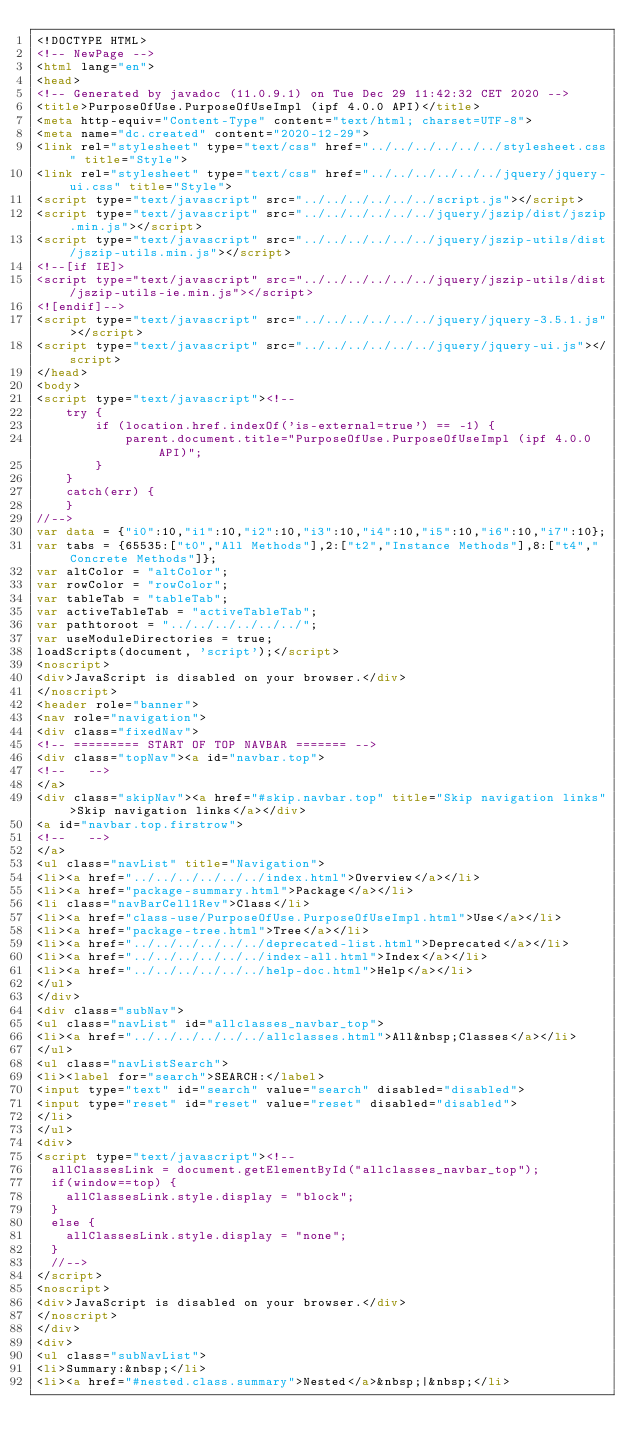Convert code to text. <code><loc_0><loc_0><loc_500><loc_500><_HTML_><!DOCTYPE HTML>
<!-- NewPage -->
<html lang="en">
<head>
<!-- Generated by javadoc (11.0.9.1) on Tue Dec 29 11:42:32 CET 2020 -->
<title>PurposeOfUse.PurposeOfUseImpl (ipf 4.0.0 API)</title>
<meta http-equiv="Content-Type" content="text/html; charset=UTF-8">
<meta name="dc.created" content="2020-12-29">
<link rel="stylesheet" type="text/css" href="../../../../../../stylesheet.css" title="Style">
<link rel="stylesheet" type="text/css" href="../../../../../../jquery/jquery-ui.css" title="Style">
<script type="text/javascript" src="../../../../../../script.js"></script>
<script type="text/javascript" src="../../../../../../jquery/jszip/dist/jszip.min.js"></script>
<script type="text/javascript" src="../../../../../../jquery/jszip-utils/dist/jszip-utils.min.js"></script>
<!--[if IE]>
<script type="text/javascript" src="../../../../../../jquery/jszip-utils/dist/jszip-utils-ie.min.js"></script>
<![endif]-->
<script type="text/javascript" src="../../../../../../jquery/jquery-3.5.1.js"></script>
<script type="text/javascript" src="../../../../../../jquery/jquery-ui.js"></script>
</head>
<body>
<script type="text/javascript"><!--
    try {
        if (location.href.indexOf('is-external=true') == -1) {
            parent.document.title="PurposeOfUse.PurposeOfUseImpl (ipf 4.0.0 API)";
        }
    }
    catch(err) {
    }
//-->
var data = {"i0":10,"i1":10,"i2":10,"i3":10,"i4":10,"i5":10,"i6":10,"i7":10};
var tabs = {65535:["t0","All Methods"],2:["t2","Instance Methods"],8:["t4","Concrete Methods"]};
var altColor = "altColor";
var rowColor = "rowColor";
var tableTab = "tableTab";
var activeTableTab = "activeTableTab";
var pathtoroot = "../../../../../../";
var useModuleDirectories = true;
loadScripts(document, 'script');</script>
<noscript>
<div>JavaScript is disabled on your browser.</div>
</noscript>
<header role="banner">
<nav role="navigation">
<div class="fixedNav">
<!-- ========= START OF TOP NAVBAR ======= -->
<div class="topNav"><a id="navbar.top">
<!--   -->
</a>
<div class="skipNav"><a href="#skip.navbar.top" title="Skip navigation links">Skip navigation links</a></div>
<a id="navbar.top.firstrow">
<!--   -->
</a>
<ul class="navList" title="Navigation">
<li><a href="../../../../../../index.html">Overview</a></li>
<li><a href="package-summary.html">Package</a></li>
<li class="navBarCell1Rev">Class</li>
<li><a href="class-use/PurposeOfUse.PurposeOfUseImpl.html">Use</a></li>
<li><a href="package-tree.html">Tree</a></li>
<li><a href="../../../../../../deprecated-list.html">Deprecated</a></li>
<li><a href="../../../../../../index-all.html">Index</a></li>
<li><a href="../../../../../../help-doc.html">Help</a></li>
</ul>
</div>
<div class="subNav">
<ul class="navList" id="allclasses_navbar_top">
<li><a href="../../../../../../allclasses.html">All&nbsp;Classes</a></li>
</ul>
<ul class="navListSearch">
<li><label for="search">SEARCH:</label>
<input type="text" id="search" value="search" disabled="disabled">
<input type="reset" id="reset" value="reset" disabled="disabled">
</li>
</ul>
<div>
<script type="text/javascript"><!--
  allClassesLink = document.getElementById("allclasses_navbar_top");
  if(window==top) {
    allClassesLink.style.display = "block";
  }
  else {
    allClassesLink.style.display = "none";
  }
  //-->
</script>
<noscript>
<div>JavaScript is disabled on your browser.</div>
</noscript>
</div>
<div>
<ul class="subNavList">
<li>Summary:&nbsp;</li>
<li><a href="#nested.class.summary">Nested</a>&nbsp;|&nbsp;</li></code> 